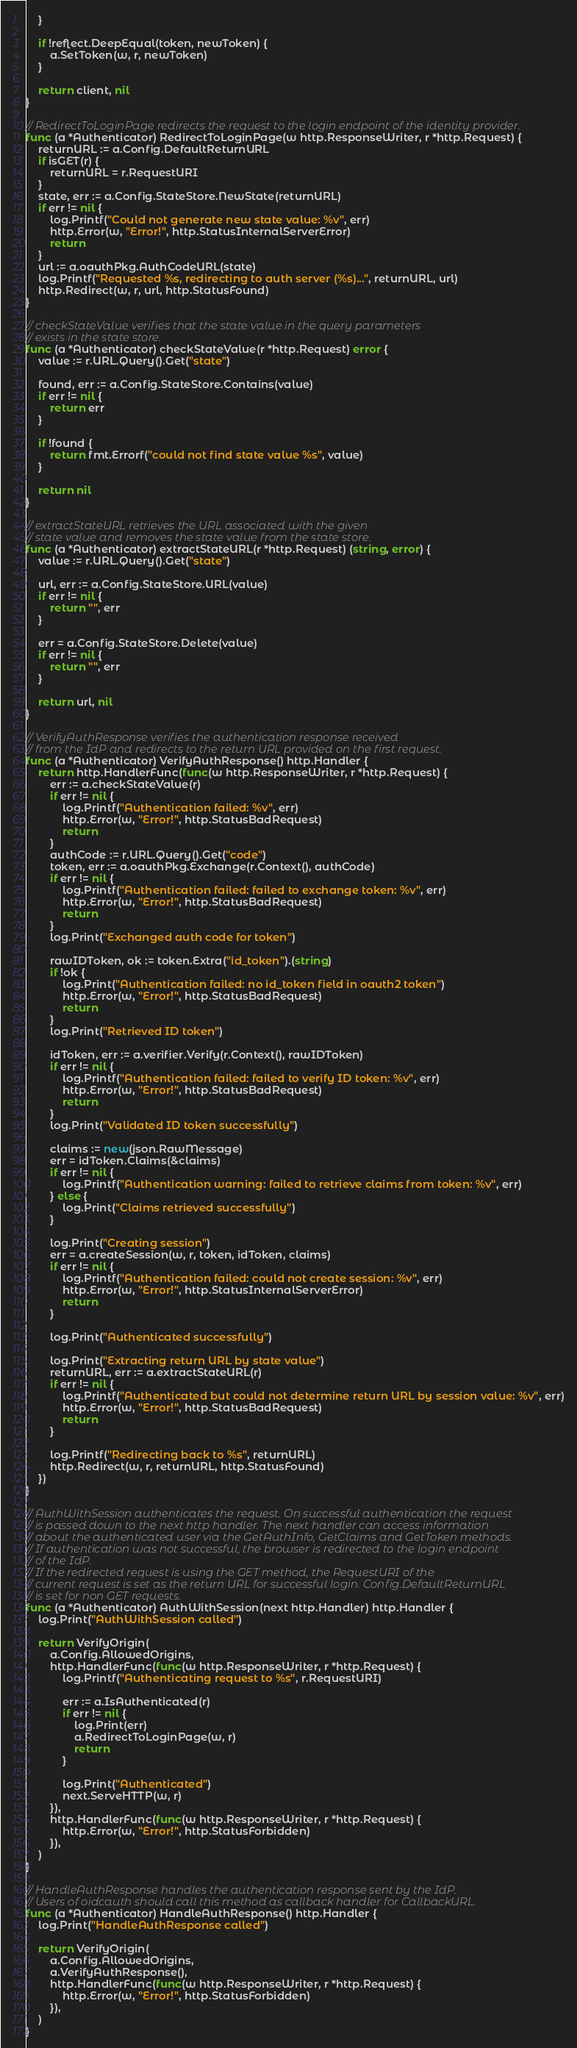<code> <loc_0><loc_0><loc_500><loc_500><_Go_>	}

	if !reflect.DeepEqual(token, newToken) {
		a.SetToken(w, r, newToken)
	}

	return client, nil
}

// RedirectToLoginPage redirects the request to the login endpoint of the identity provider.
func (a *Authenticator) RedirectToLoginPage(w http.ResponseWriter, r *http.Request) {
	returnURL := a.Config.DefaultReturnURL
	if isGET(r) {
		returnURL = r.RequestURI
	}
	state, err := a.Config.StateStore.NewState(returnURL)
	if err != nil {
		log.Printf("Could not generate new state value: %v", err)
		http.Error(w, "Error!", http.StatusInternalServerError)
		return
	}
	url := a.oauthPkg.AuthCodeURL(state)
	log.Printf("Requested %s, redirecting to auth server (%s)...", returnURL, url)
	http.Redirect(w, r, url, http.StatusFound)
}

// checkStateValue verifies that the state value in the query parameters
// exists in the state store.
func (a *Authenticator) checkStateValue(r *http.Request) error {
	value := r.URL.Query().Get("state")

	found, err := a.Config.StateStore.Contains(value)
	if err != nil {
		return err
	}

	if !found {
		return fmt.Errorf("could not find state value %s", value)
	}

	return nil
}

// extractStateURL retrieves the URL associated with the given
// state value and removes the state value from the state store.
func (a *Authenticator) extractStateURL(r *http.Request) (string, error) {
	value := r.URL.Query().Get("state")

	url, err := a.Config.StateStore.URL(value)
	if err != nil {
		return "", err
	}

	err = a.Config.StateStore.Delete(value)
	if err != nil {
		return "", err
	}

	return url, nil
}

// VerifyAuthResponse verifies the authentication response received
// from the IdP and redirects to the return URL provided on the first request.
func (a *Authenticator) VerifyAuthResponse() http.Handler {
	return http.HandlerFunc(func(w http.ResponseWriter, r *http.Request) {
		err := a.checkStateValue(r)
		if err != nil {
			log.Printf("Authentication failed: %v", err)
			http.Error(w, "Error!", http.StatusBadRequest)
			return
		}
		authCode := r.URL.Query().Get("code")
		token, err := a.oauthPkg.Exchange(r.Context(), authCode)
		if err != nil {
			log.Printf("Authentication failed: failed to exchange token: %v", err)
			http.Error(w, "Error!", http.StatusBadRequest)
			return
		}
		log.Print("Exchanged auth code for token")

		rawIDToken, ok := token.Extra("id_token").(string)
		if !ok {
			log.Print("Authentication failed: no id_token field in oauth2 token")
			http.Error(w, "Error!", http.StatusBadRequest)
			return
		}
		log.Print("Retrieved ID token")

		idToken, err := a.verifier.Verify(r.Context(), rawIDToken)
		if err != nil {
			log.Printf("Authentication failed: failed to verify ID token: %v", err)
			http.Error(w, "Error!", http.StatusBadRequest)
			return
		}
		log.Print("Validated ID token successfully")

		claims := new(json.RawMessage)
		err = idToken.Claims(&claims)
		if err != nil {
			log.Printf("Authentication warning: failed to retrieve claims from token: %v", err)
		} else {
			log.Print("Claims retrieved successfully")
		}

		log.Print("Creating session")
		err = a.createSession(w, r, token, idToken, claims)
		if err != nil {
			log.Printf("Authentication failed: could not create session: %v", err)
			http.Error(w, "Error!", http.StatusInternalServerError)
			return
		}

		log.Print("Authenticated successfully")

		log.Print("Extracting return URL by state value")
		returnURL, err := a.extractStateURL(r)
		if err != nil {
			log.Printf("Authenticated but could not determine return URL by session value: %v", err)
			http.Error(w, "Error!", http.StatusBadRequest)
			return
		}

		log.Printf("Redirecting back to %s", returnURL)
		http.Redirect(w, r, returnURL, http.StatusFound)
	})
}

// AuthWithSession authenticates the request. On successful authentication the request
// is passed down to the next http handler. The next handler can access information
// about the authenticated user via the GetAuthInfo, GetClaims and GetToken methods.
// If authentication was not successful, the browser is redirected to the login endpoint
// of the IdP.
// If the redirected request is using the GET method, the RequestURI of the
// current request is set as the return URL for successful login. Config.DefaultReturnURL
// is set for non GET requests.
func (a *Authenticator) AuthWithSession(next http.Handler) http.Handler {
	log.Print("AuthWithSession called")

	return VerifyOrigin(
		a.Config.AllowedOrigins,
		http.HandlerFunc(func(w http.ResponseWriter, r *http.Request) {
			log.Printf("Authenticating request to %s", r.RequestURI)

			err := a.IsAuthenticated(r)
			if err != nil {
				log.Print(err)
				a.RedirectToLoginPage(w, r)
				return
			}

			log.Print("Authenticated")
			next.ServeHTTP(w, r)
		}),
		http.HandlerFunc(func(w http.ResponseWriter, r *http.Request) {
			http.Error(w, "Error!", http.StatusForbidden)
		}),
	)
}

// HandleAuthResponse handles the authentication response sent by the IdP.
// Users of oidcauth should call this method as callback handler for CallbackURL.
func (a *Authenticator) HandleAuthResponse() http.Handler {
	log.Print("HandleAuthResponse called")

	return VerifyOrigin(
		a.Config.AllowedOrigins,
		a.VerifyAuthResponse(),
		http.HandlerFunc(func(w http.ResponseWriter, r *http.Request) {
			http.Error(w, "Error!", http.StatusForbidden)
		}),
	)
}
</code> 